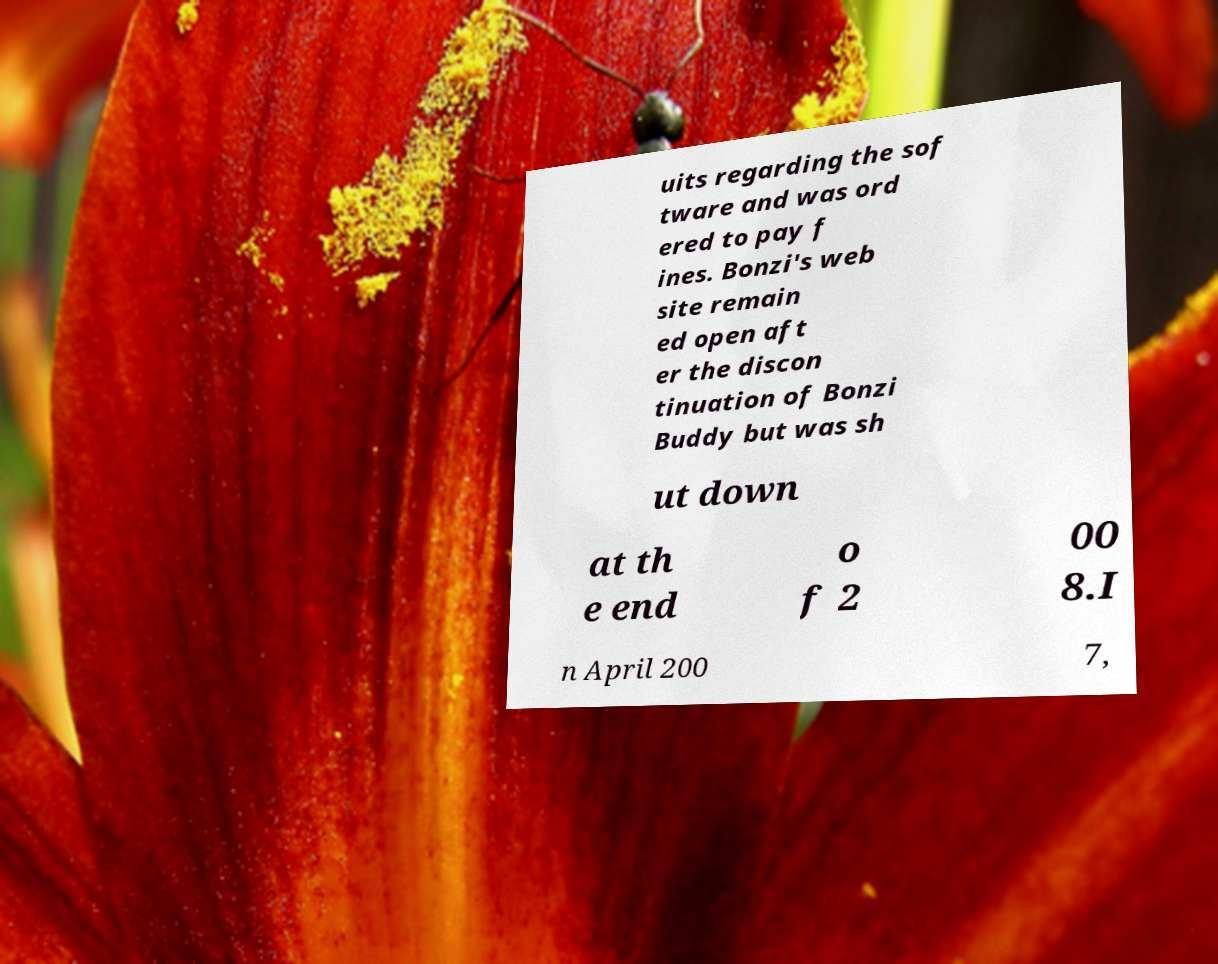Please identify and transcribe the text found in this image. uits regarding the sof tware and was ord ered to pay f ines. Bonzi's web site remain ed open aft er the discon tinuation of Bonzi Buddy but was sh ut down at th e end o f 2 00 8.I n April 200 7, 